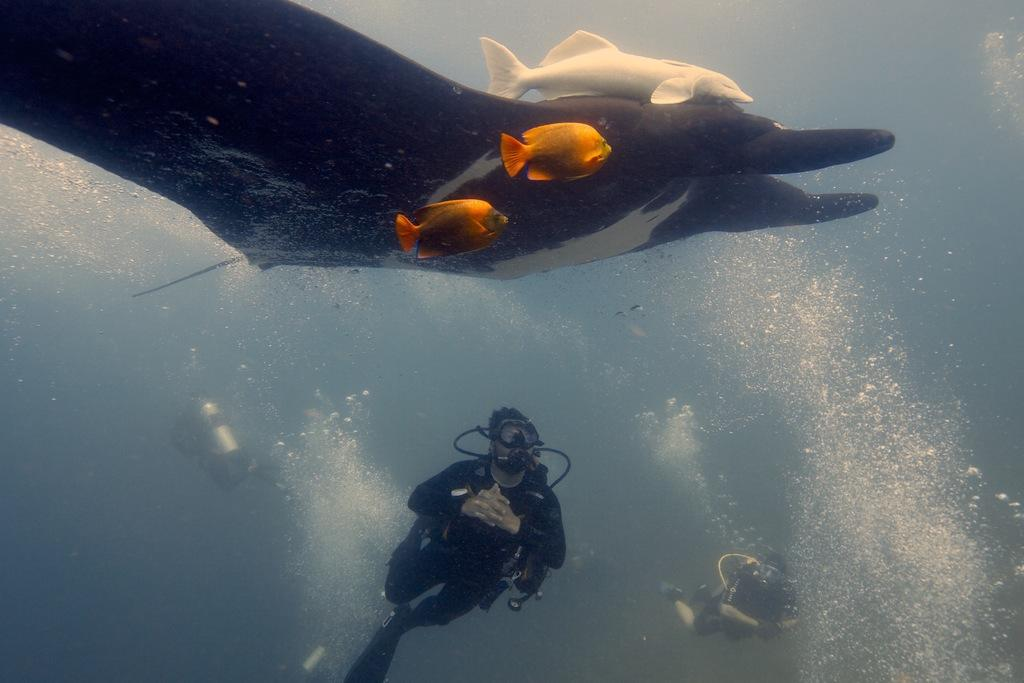How many people are in the image? There are three persons in the image. What are the persons doing in the image? The persons are diving in the water. What objects are the persons holding while diving? The persons are holding cylinders. What else can be seen in the water besides the divers? There are fishes in the water. What is the acoustics like in the water in the image? The provided facts do not mention anything about the acoustics in the water, so it cannot be determined from the image. --- Facts: 1. There is a person holding a camera in the image. 2. The person is standing on a bridge. 3. The bridge is over a river. 4. There are trees on both sides of the river. Absurd Topics: parrot, sand, volleyball Conversation: What is the person in the image doing? The person in the image is holding a camera. Where is the person standing in the image? The person is standing on a bridge. What is the bridge positioned over in the image? The bridge is over a river. What can be seen on both sides of the river in the image? There are trees on both sides of the river. Reasoning: Let's think step by step in order to produce the conversation. We start by identifying the main subject in the image, which is the person holding a camera. Then, we describe the person's location, which is on a bridge. Next, we mention the bridge's position, which is over a river. Finally, we expand the conversation to include other elements in the image, such as the trees on both sides of the river. Absurd Question/Answer: Can you see a parrot flying over the sand in the image? There is no parrot or sand present in the image; it features a person holding a camera on a bridge over a river with trees on both sides. 